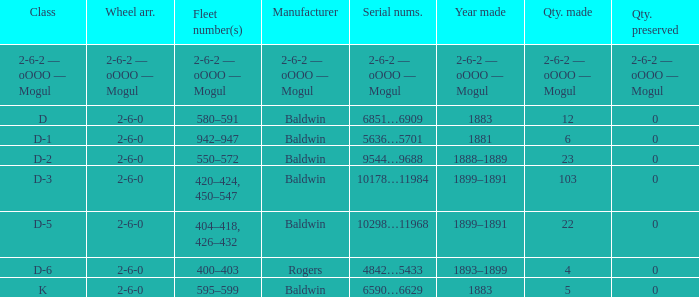What is the class when the quantity perserved is 0 and the quantity made is 5? K. 